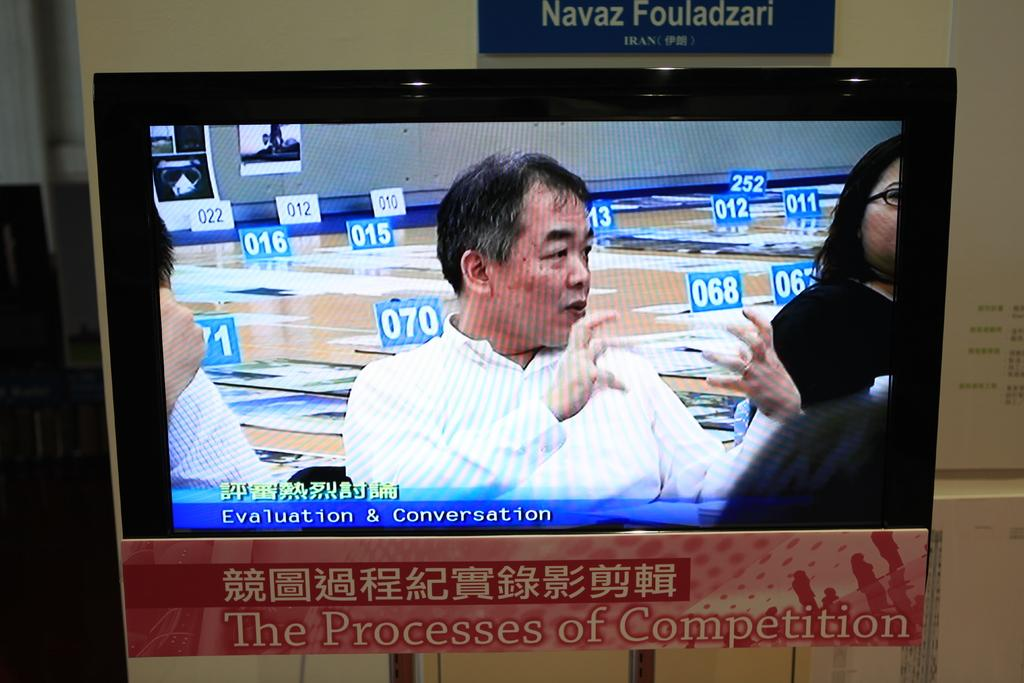<image>
Present a compact description of the photo's key features. A man on a monitor is seen above the words Evaluation & Conversation. 